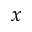<formula> <loc_0><loc_0><loc_500><loc_500>x</formula> 